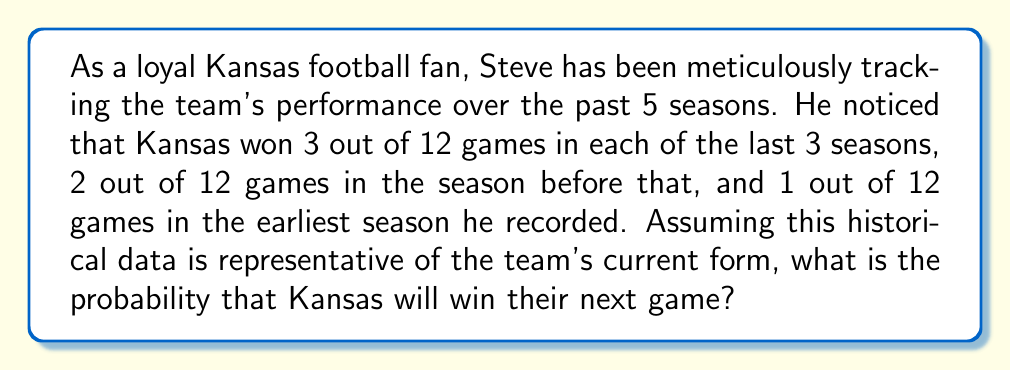Can you solve this math problem? To solve this problem, we need to calculate the overall win probability based on the given historical data. Let's break it down step-by-step:

1. Calculate the total number of games played:
   $5 \text{ seasons} \times 12 \text{ games per season} = 60 \text{ total games}$

2. Calculate the total number of wins:
   $3 + 3 + 3 + 2 + 1 = 12 \text{ total wins}$

3. Calculate the probability of winning using the formula:
   $$P(\text{win}) = \frac{\text{number of favorable outcomes}}{\text{total number of possible outcomes}}$$

   In this case:
   $$P(\text{win}) = \frac{\text{total wins}}{\text{total games}} = \frac{12}{60}$$

4. Simplify the fraction:
   $$P(\text{win}) = \frac{12}{60} = \frac{1}{5} = 0.2$$

Therefore, based on the historical data provided, the probability of Kansas winning their next game is $\frac{1}{5}$ or 0.2 or 20%.
Answer: $\frac{1}{5}$ or 0.2 or 20% 